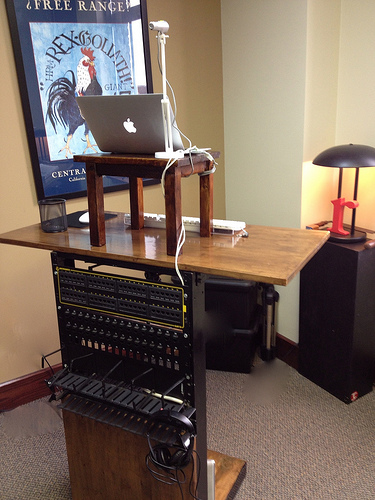<image>
Is the lamp on the table? No. The lamp is not positioned on the table. They may be near each other, but the lamp is not supported by or resting on top of the table. Where is the laptop in relation to the lamp? Is it to the left of the lamp? Yes. From this viewpoint, the laptop is positioned to the left side relative to the lamp. 